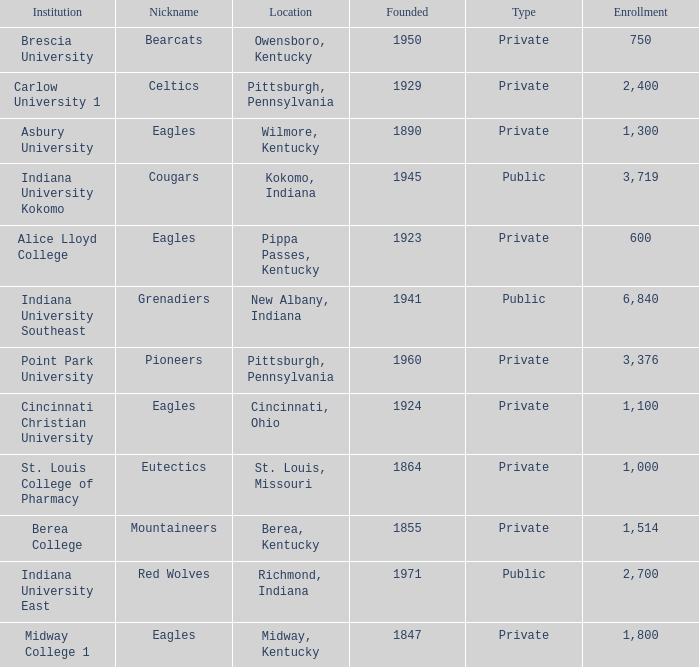Which college's enrollment is less than 1,000? Alice Lloyd College, Brescia University. 